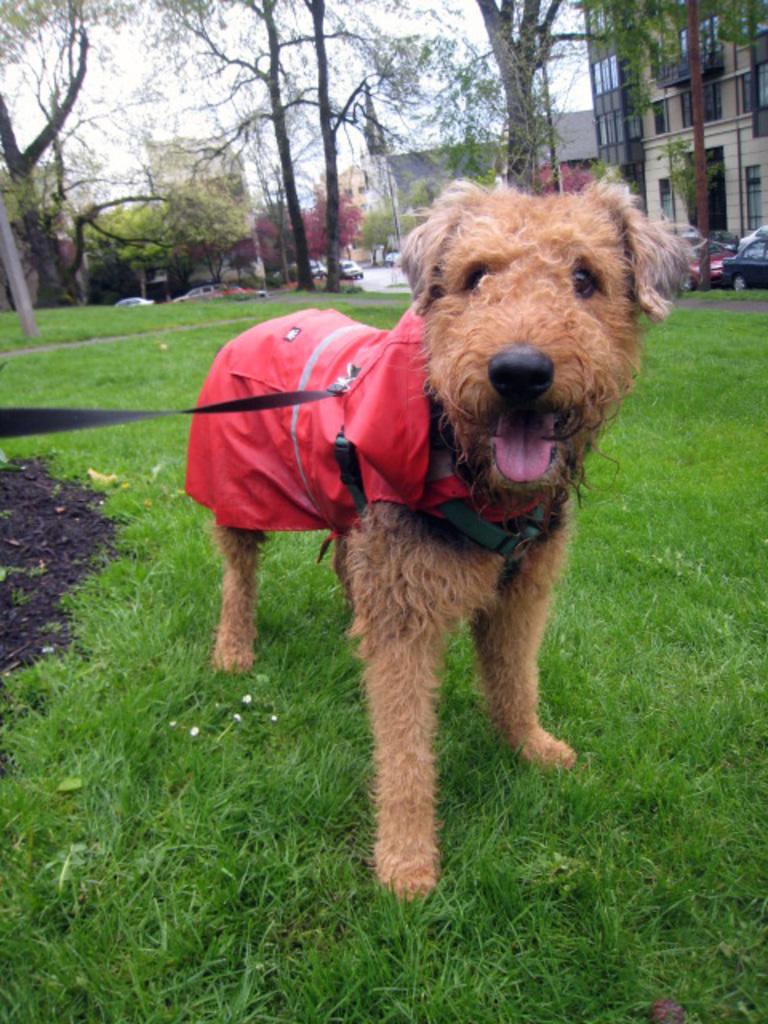How would you summarize this image in a sentence or two? In this image we can see a dog is standing on the grass on the ground and there is a belt tied to the dog. In the background we can see trees, buildings, windows, roofs, poles, vehicles on the road and the sky. 